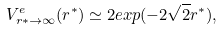<formula> <loc_0><loc_0><loc_500><loc_500>V _ { r * \to \infty } ^ { e } ( r ^ { * } ) \simeq 2 e x p ( - 2 \sqrt { 2 } r ^ { * } ) ,</formula> 